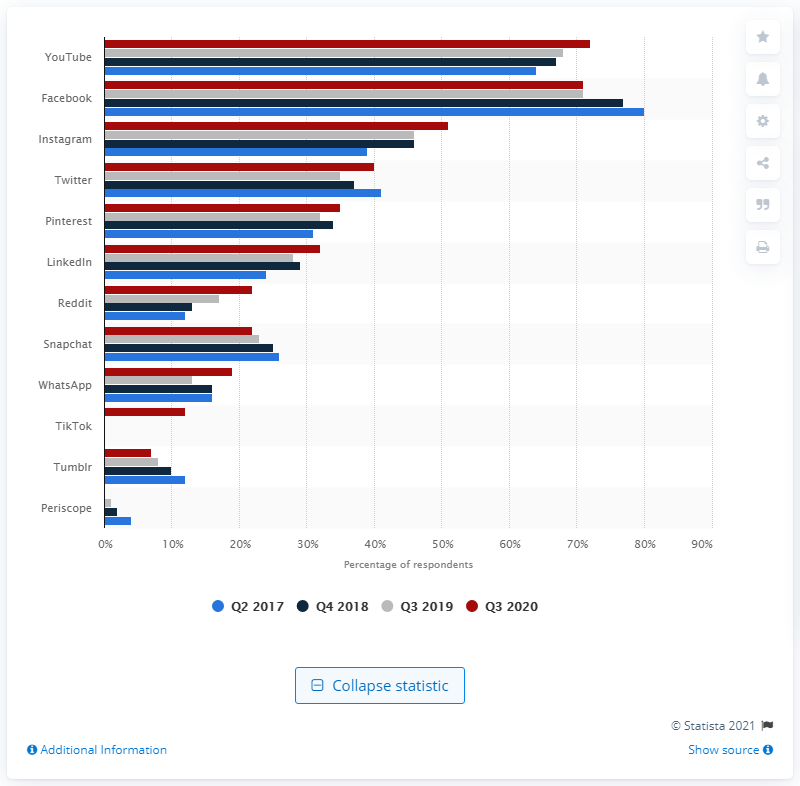Indicate a few pertinent items in this graphic. Snapchat is the only social media platform that users are abandoning. 